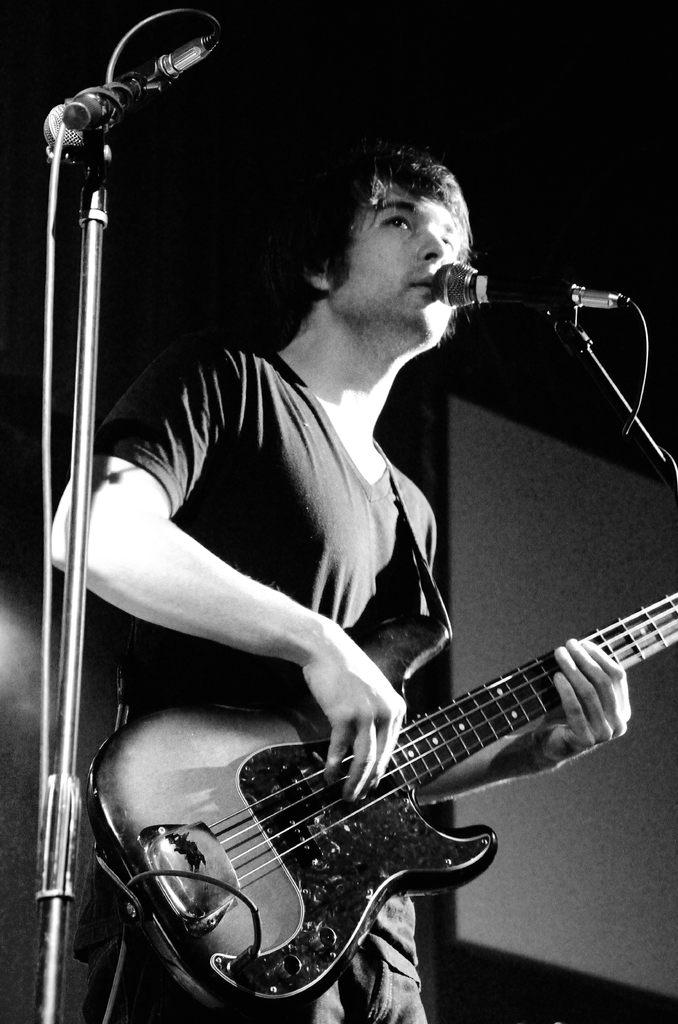What is the man in the image doing? The man is singing in the image. What is the man using while singing? The man is using a microphone in the image. What musical instrument is the man playing? The man is playing a guitar in the image. Can you tell me how many ducks are present in the image? There are no ducks present in the image. What position does the man hold in the class? There is no mention of a class or position in the image. 